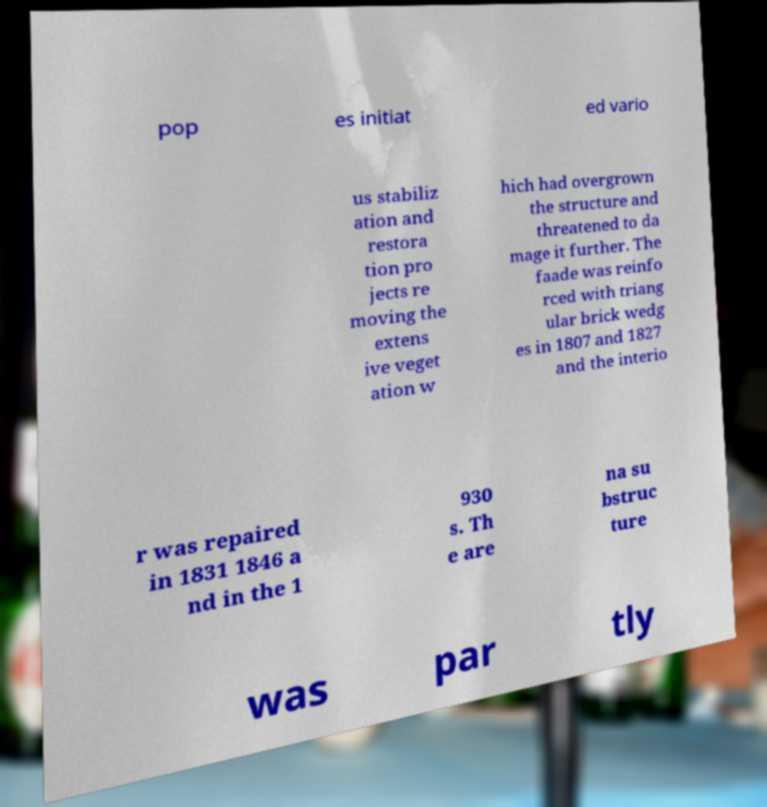Could you extract and type out the text from this image? pop es initiat ed vario us stabiliz ation and restora tion pro jects re moving the extens ive veget ation w hich had overgrown the structure and threatened to da mage it further. The faade was reinfo rced with triang ular brick wedg es in 1807 and 1827 and the interio r was repaired in 1831 1846 a nd in the 1 930 s. Th e are na su bstruc ture was par tly 